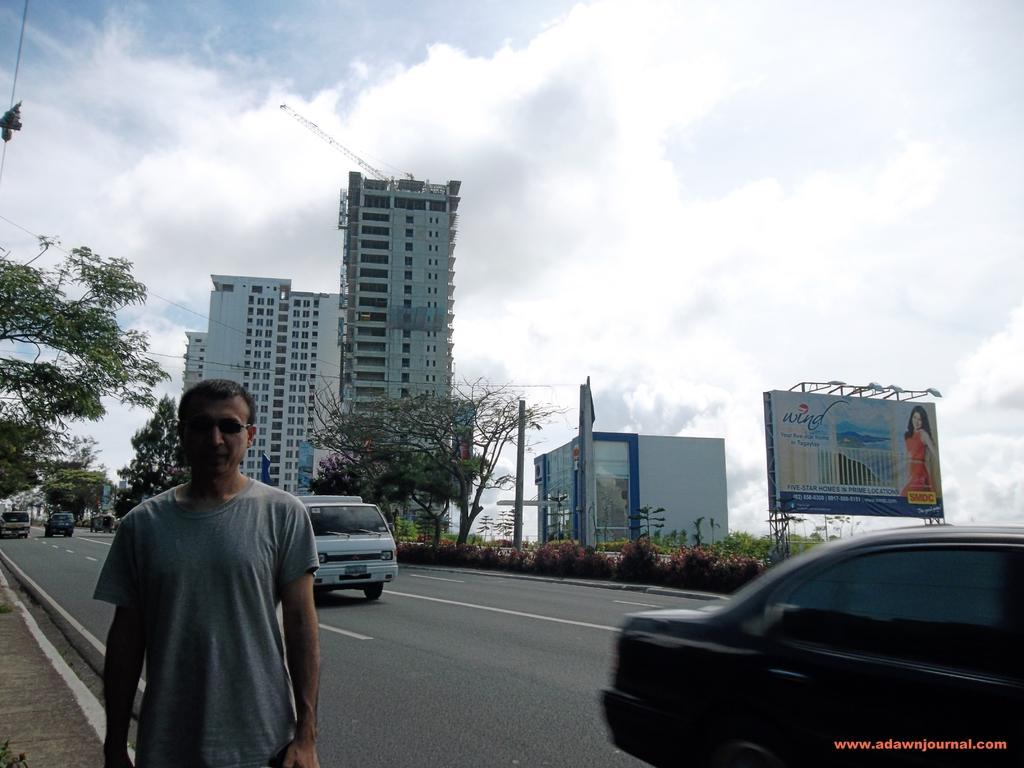Describe this image in one or two sentences. There is a man standing and we can see vehicles on the road. We can see plants, hoarding, trees and wires. In the background we can see buildings and sky. 